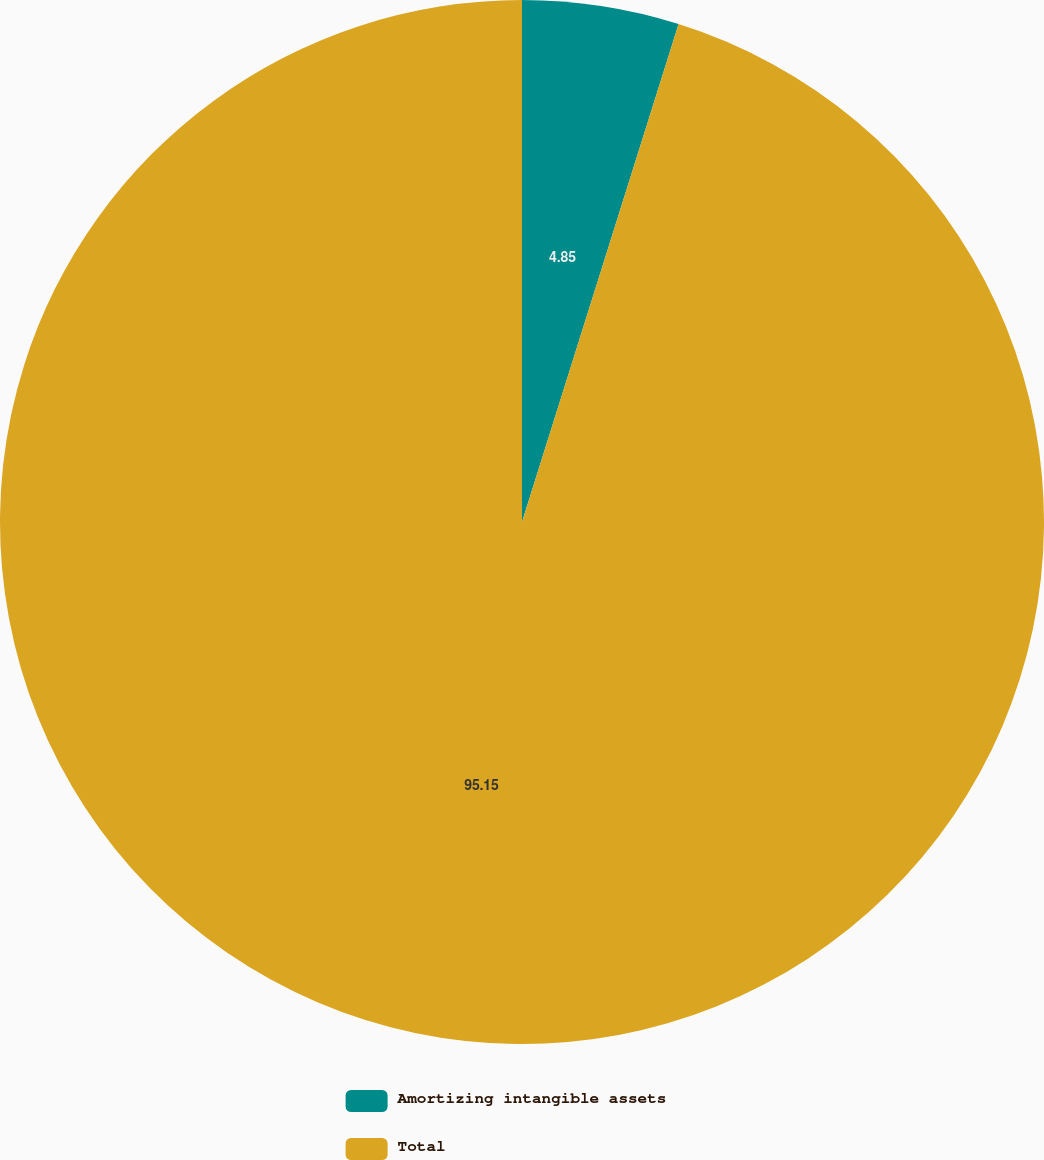Convert chart to OTSL. <chart><loc_0><loc_0><loc_500><loc_500><pie_chart><fcel>Amortizing intangible assets<fcel>Total<nl><fcel>4.85%<fcel>95.15%<nl></chart> 